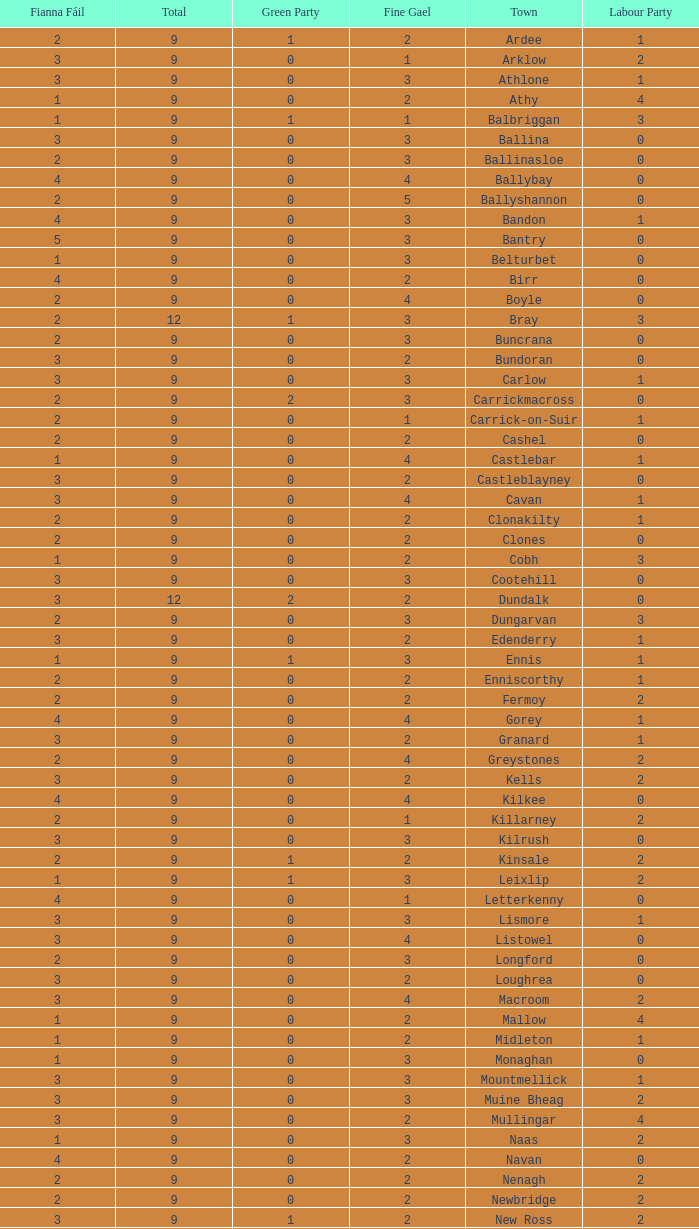How many are in the Labour Party of a Fianna Fail of 3 with a total higher than 9 and more than 2 in the Green Party? None. 